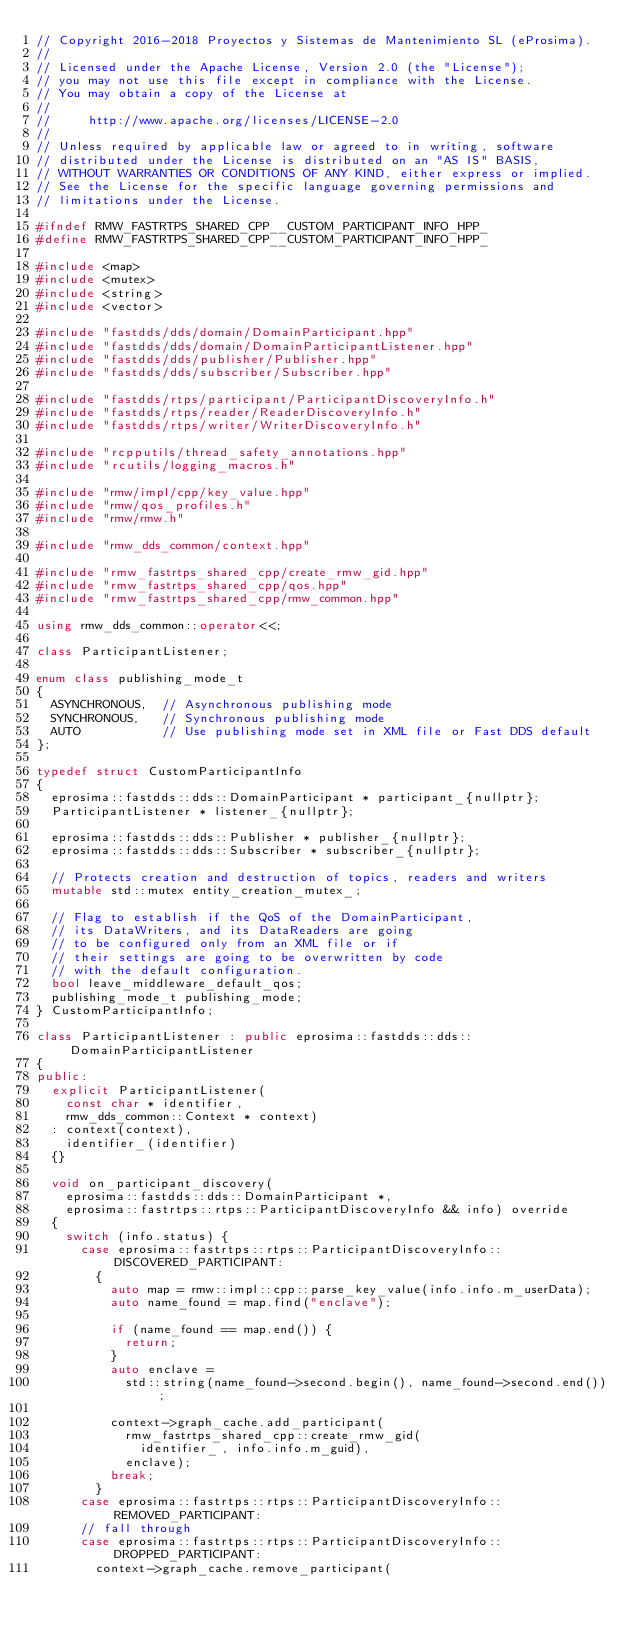<code> <loc_0><loc_0><loc_500><loc_500><_C++_>// Copyright 2016-2018 Proyectos y Sistemas de Mantenimiento SL (eProsima).
//
// Licensed under the Apache License, Version 2.0 (the "License");
// you may not use this file except in compliance with the License.
// You may obtain a copy of the License at
//
//     http://www.apache.org/licenses/LICENSE-2.0
//
// Unless required by applicable law or agreed to in writing, software
// distributed under the License is distributed on an "AS IS" BASIS,
// WITHOUT WARRANTIES OR CONDITIONS OF ANY KIND, either express or implied.
// See the License for the specific language governing permissions and
// limitations under the License.

#ifndef RMW_FASTRTPS_SHARED_CPP__CUSTOM_PARTICIPANT_INFO_HPP_
#define RMW_FASTRTPS_SHARED_CPP__CUSTOM_PARTICIPANT_INFO_HPP_

#include <map>
#include <mutex>
#include <string>
#include <vector>

#include "fastdds/dds/domain/DomainParticipant.hpp"
#include "fastdds/dds/domain/DomainParticipantListener.hpp"
#include "fastdds/dds/publisher/Publisher.hpp"
#include "fastdds/dds/subscriber/Subscriber.hpp"

#include "fastdds/rtps/participant/ParticipantDiscoveryInfo.h"
#include "fastdds/rtps/reader/ReaderDiscoveryInfo.h"
#include "fastdds/rtps/writer/WriterDiscoveryInfo.h"

#include "rcpputils/thread_safety_annotations.hpp"
#include "rcutils/logging_macros.h"

#include "rmw/impl/cpp/key_value.hpp"
#include "rmw/qos_profiles.h"
#include "rmw/rmw.h"

#include "rmw_dds_common/context.hpp"

#include "rmw_fastrtps_shared_cpp/create_rmw_gid.hpp"
#include "rmw_fastrtps_shared_cpp/qos.hpp"
#include "rmw_fastrtps_shared_cpp/rmw_common.hpp"

using rmw_dds_common::operator<<;

class ParticipantListener;

enum class publishing_mode_t
{
  ASYNCHRONOUS,  // Asynchronous publishing mode
  SYNCHRONOUS,   // Synchronous publishing mode
  AUTO           // Use publishing mode set in XML file or Fast DDS default
};

typedef struct CustomParticipantInfo
{
  eprosima::fastdds::dds::DomainParticipant * participant_{nullptr};
  ParticipantListener * listener_{nullptr};

  eprosima::fastdds::dds::Publisher * publisher_{nullptr};
  eprosima::fastdds::dds::Subscriber * subscriber_{nullptr};

  // Protects creation and destruction of topics, readers and writers
  mutable std::mutex entity_creation_mutex_;

  // Flag to establish if the QoS of the DomainParticipant,
  // its DataWriters, and its DataReaders are going
  // to be configured only from an XML file or if
  // their settings are going to be overwritten by code
  // with the default configuration.
  bool leave_middleware_default_qos;
  publishing_mode_t publishing_mode;
} CustomParticipantInfo;

class ParticipantListener : public eprosima::fastdds::dds::DomainParticipantListener
{
public:
  explicit ParticipantListener(
    const char * identifier,
    rmw_dds_common::Context * context)
  : context(context),
    identifier_(identifier)
  {}

  void on_participant_discovery(
    eprosima::fastdds::dds::DomainParticipant *,
    eprosima::fastrtps::rtps::ParticipantDiscoveryInfo && info) override
  {
    switch (info.status) {
      case eprosima::fastrtps::rtps::ParticipantDiscoveryInfo::DISCOVERED_PARTICIPANT:
        {
          auto map = rmw::impl::cpp::parse_key_value(info.info.m_userData);
          auto name_found = map.find("enclave");

          if (name_found == map.end()) {
            return;
          }
          auto enclave =
            std::string(name_found->second.begin(), name_found->second.end());

          context->graph_cache.add_participant(
            rmw_fastrtps_shared_cpp::create_rmw_gid(
              identifier_, info.info.m_guid),
            enclave);
          break;
        }
      case eprosima::fastrtps::rtps::ParticipantDiscoveryInfo::REMOVED_PARTICIPANT:
      // fall through
      case eprosima::fastrtps::rtps::ParticipantDiscoveryInfo::DROPPED_PARTICIPANT:
        context->graph_cache.remove_participant(</code> 